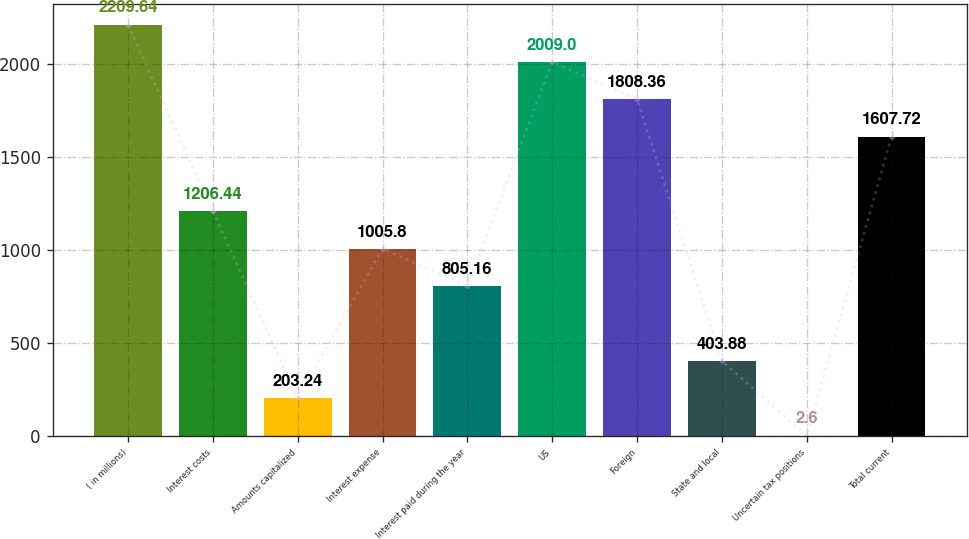<chart> <loc_0><loc_0><loc_500><loc_500><bar_chart><fcel>( in millions)<fcel>Interest costs<fcel>Amounts capitalized<fcel>Interest expense<fcel>Interest paid during the year<fcel>US<fcel>Foreign<fcel>State and local<fcel>Uncertain tax positions<fcel>Total current<nl><fcel>2209.64<fcel>1206.44<fcel>203.24<fcel>1005.8<fcel>805.16<fcel>2009<fcel>1808.36<fcel>403.88<fcel>2.6<fcel>1607.72<nl></chart> 